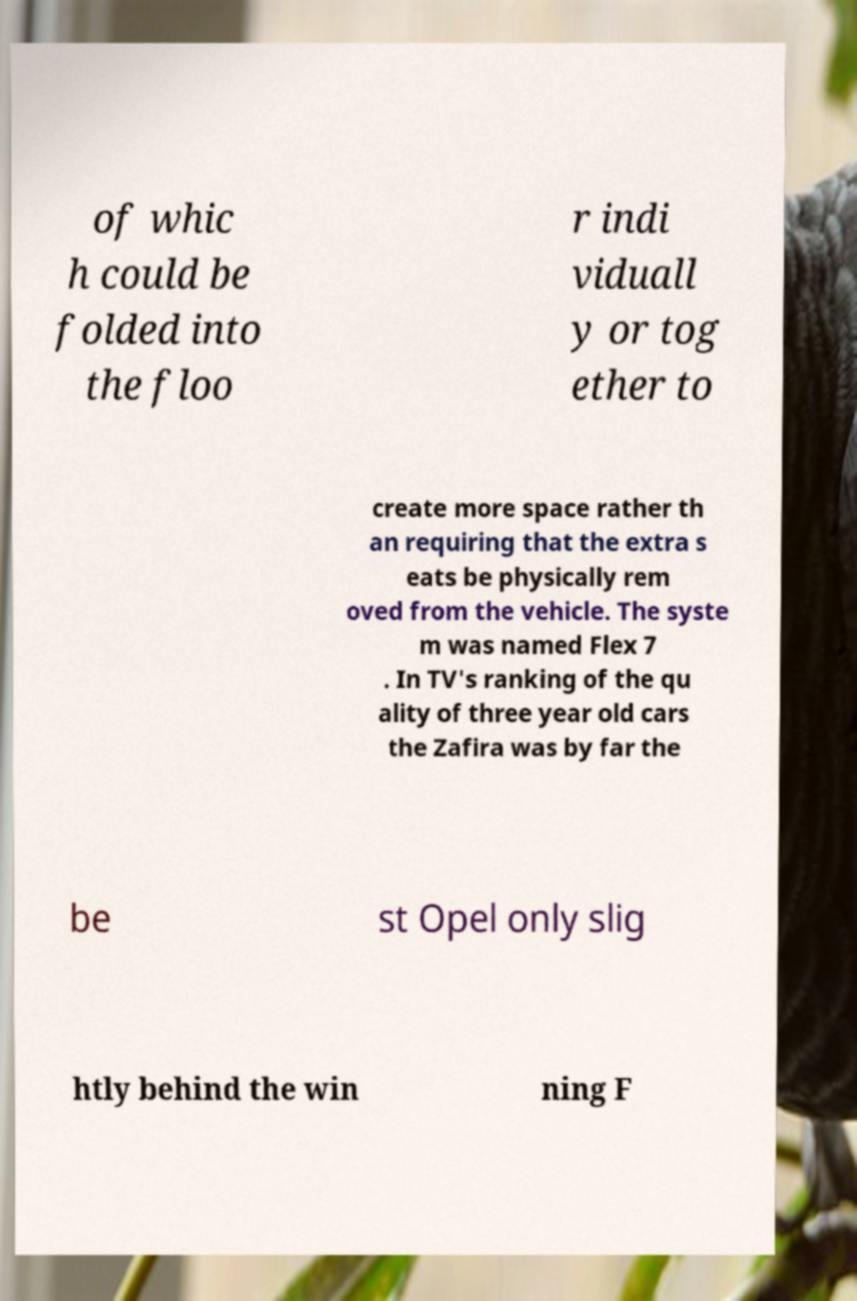What messages or text are displayed in this image? I need them in a readable, typed format. of whic h could be folded into the floo r indi viduall y or tog ether to create more space rather th an requiring that the extra s eats be physically rem oved from the vehicle. The syste m was named Flex 7 . In TV's ranking of the qu ality of three year old cars the Zafira was by far the be st Opel only slig htly behind the win ning F 